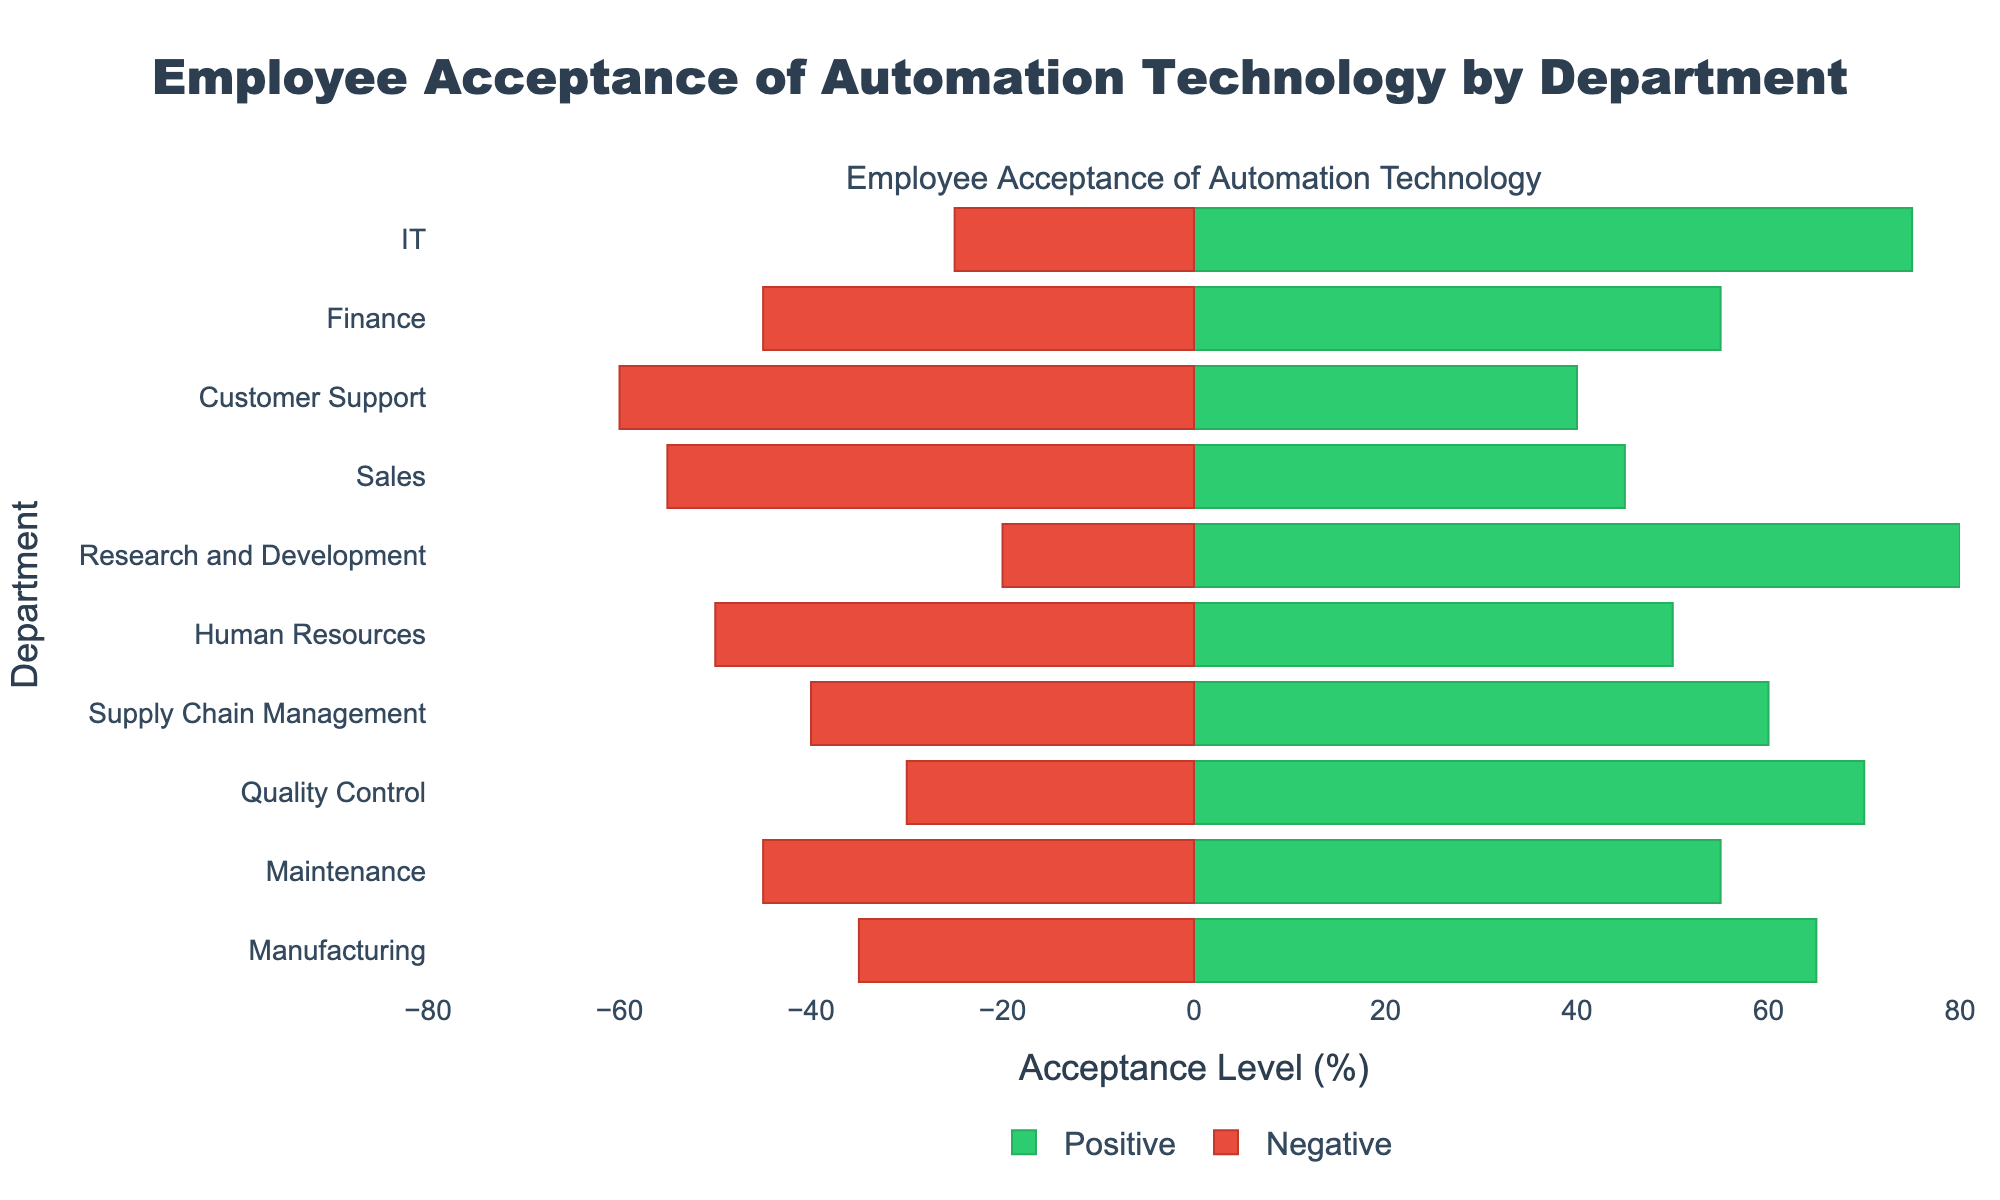Which department has the highest positive acceptance level? From the figure, the department with the highest bar on the positive side (green) indicates the highest positive acceptance. The Research and Development department has the longest positive bar, showing 80%.
Answer: Research and Development Which department has a higher negative acceptance level: Maintenance or Finance? Compare the lengths of the negative bars (red) for Maintenance and Finance. Maintenance has a negative bar of -45%, and Finance also has -45%.
Answer: Equal What's the difference between positive and negative acceptance levels in the Quality Control department? From the figure, Quality Control has a positive acceptance level of 70% and a negative level of 30%. The difference is 70% - 30% = 40%.
Answer: 40% Which department shows an equal positive and negative acceptance level? Look for the department where the positive and negative bars have equal lengths. Human Resources has both bars at 50%.
Answer: Human Resources Which department has the lowest negative acceptance level? The department with the smallest negative (red) bar has the lowest negative acceptance. Research and Development has the smallest negative bar with -20%.
Answer: Research and Development Among IT, Sales, and Customer Support, which department has the highest positive acceptance level? Compare the positive (green) bars for IT (75%), Sales (45%), and Customer Support (40%). IT has the highest positive bar of 75%.
Answer: IT What is the total positive acceptance level across Manufacturing, Maintenance, and Supply Chain Management? Sum the positive acceptance levels for Manufacturing (65%), Maintenance (55%), and Supply Chain Management (60%). The total is 65% + 55% + 60% = 180%.
Answer: 180% How does the positive acceptance level in Sales compare to that in Customer Support? Compare the lengths of the positive (green) bars for Sales (45%) and Customer Support (40%). Sales has a higher positive acceptance level than Customer Support.
Answer: Sales What is the average negative acceptance level of all departments shown? Sum up the negative acceptance levels of all departments (35% + 45% + 30% + 40% + 50% + 20% + 55% + 60% + 45% + 25%) and divide by the number of departments (10). The calculation is (35 + 45 + 30 + 40 + 50 + 20 + 55 + 60 + 45 + 25) / 10 = 40.5%.
Answer: 40.5% 